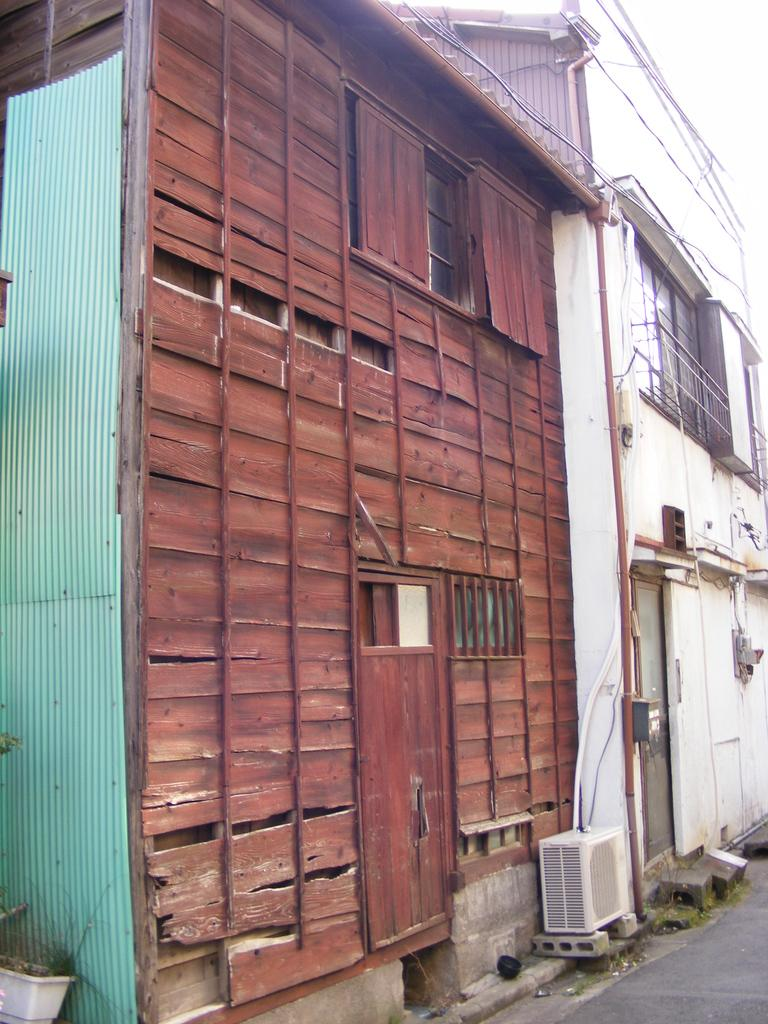What type of plant can be seen in the image? There is a houseplant in the image. What material is used for the roof in the image? Roof sheets are visible in the image. What type of pathway is present in the image? There is a road in the image. What architectural feature can be seen on the buildings in the image? There are buildings with windows in the image. What day of the week is depicted in the image? The image does not depict a specific day of the week; it shows a houseplant, roof sheets, a road, and buildings with windows. Can you tell me how many turkeys are present in the image? There are no turkeys present in the image. 